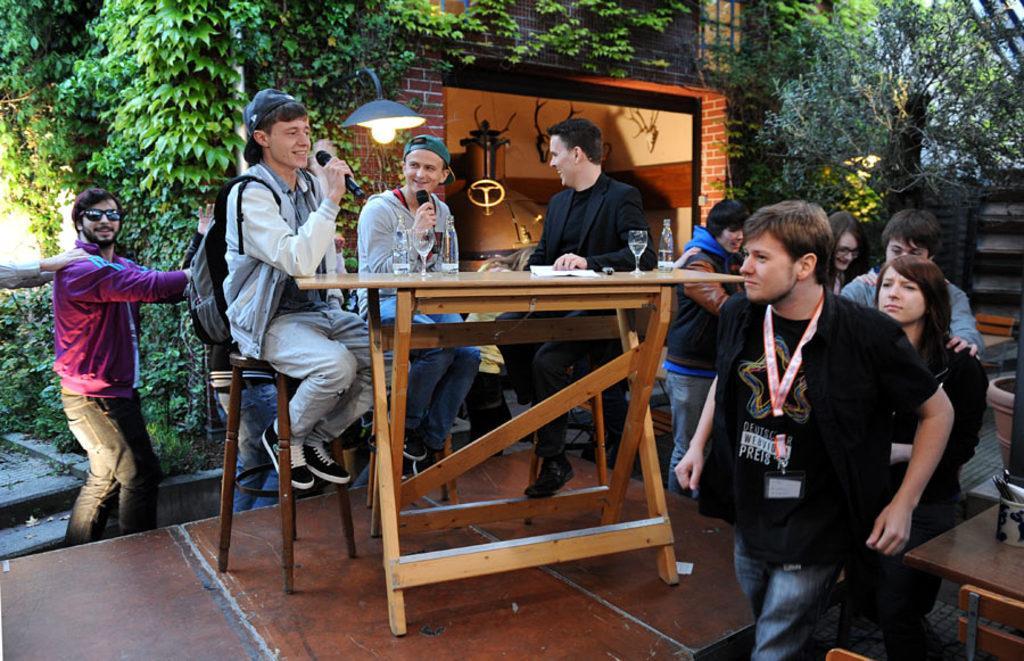Describe this image in one or two sentences. In this picture there are some people sitting on the stools in front of the table. Two of them were holding mics in their hands. Some of them were standing and walking around the table. In the background there are some trees and a building here. 